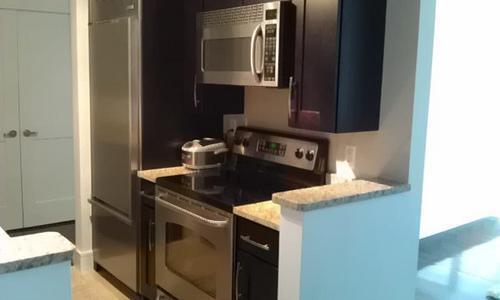How many microwaves are there?
Give a very brief answer. 1. How many ovens are in the photo?
Give a very brief answer. 1. 